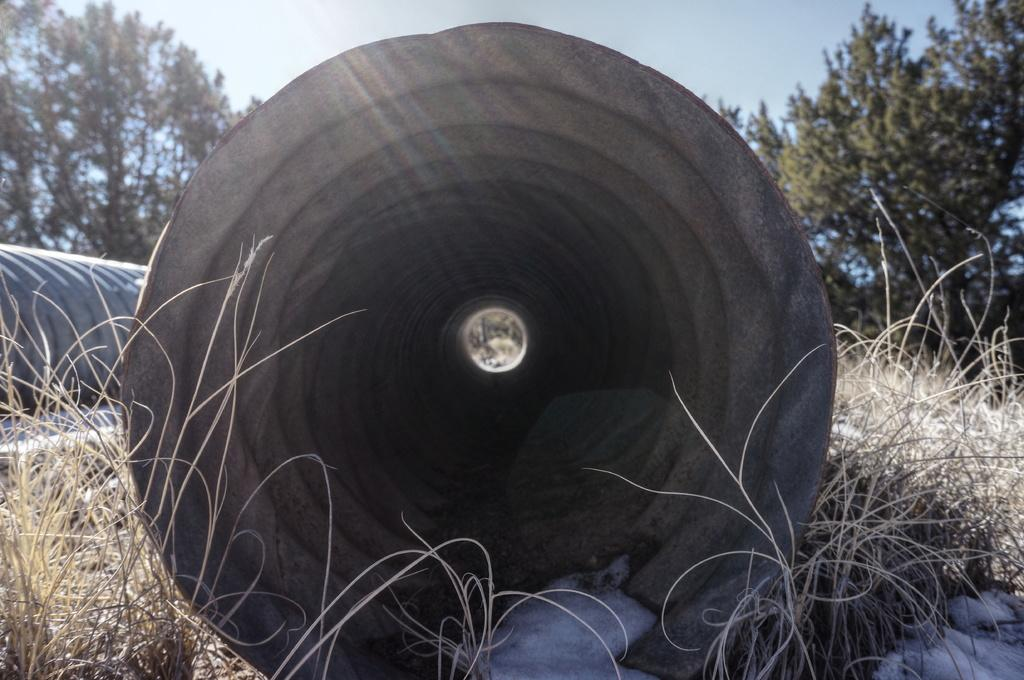What is the main structure in the middle of the picture? There is a concrete tunnel in the middle of the picture. What type of vegetation can be seen on the ground? There is dried grass on the ground. What can be seen in the background of the picture? There are trees and the sky visible in the background of the picture. How many letters are being attacked by the trees in the image? There are no letters or attacks present in the image; it features a concrete tunnel, dried grass, trees, and the sky. 